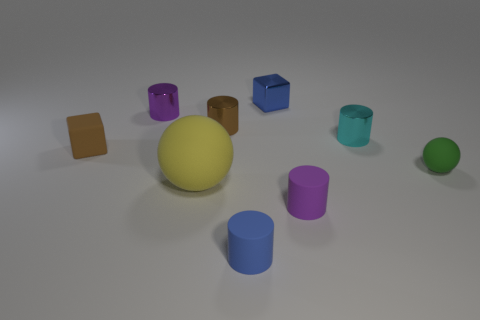Add 1 small brown metallic cylinders. How many objects exist? 10 Subtract all small blue cylinders. How many cylinders are left? 4 Subtract all red blocks. How many purple cylinders are left? 2 Subtract 3 cylinders. How many cylinders are left? 2 Subtract all blue cylinders. How many cylinders are left? 4 Subtract all balls. How many objects are left? 7 Subtract all gray cylinders. Subtract all cyan balls. How many cylinders are left? 5 Subtract all large yellow spheres. Subtract all small blue matte objects. How many objects are left? 7 Add 3 balls. How many balls are left? 5 Add 8 yellow metal blocks. How many yellow metal blocks exist? 8 